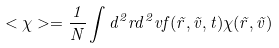<formula> <loc_0><loc_0><loc_500><loc_500>< \chi > = \frac { 1 } { N } \int d ^ { 2 } r d ^ { 2 } v f ( \vec { r } , \vec { v } , t ) \chi ( \vec { r } , \vec { v } )</formula> 